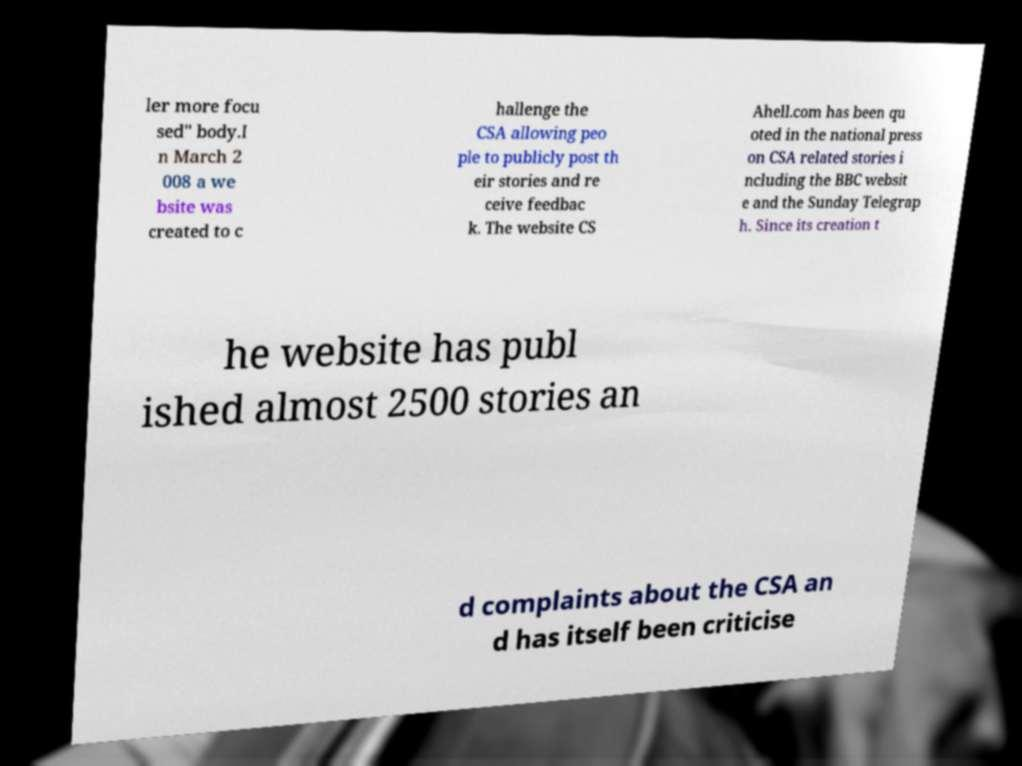For documentation purposes, I need the text within this image transcribed. Could you provide that? ler more focu sed" body.I n March 2 008 a we bsite was created to c hallenge the CSA allowing peo ple to publicly post th eir stories and re ceive feedbac k. The website CS Ahell.com has been qu oted in the national press on CSA related stories i ncluding the BBC websit e and the Sunday Telegrap h. Since its creation t he website has publ ished almost 2500 stories an d complaints about the CSA an d has itself been criticise 